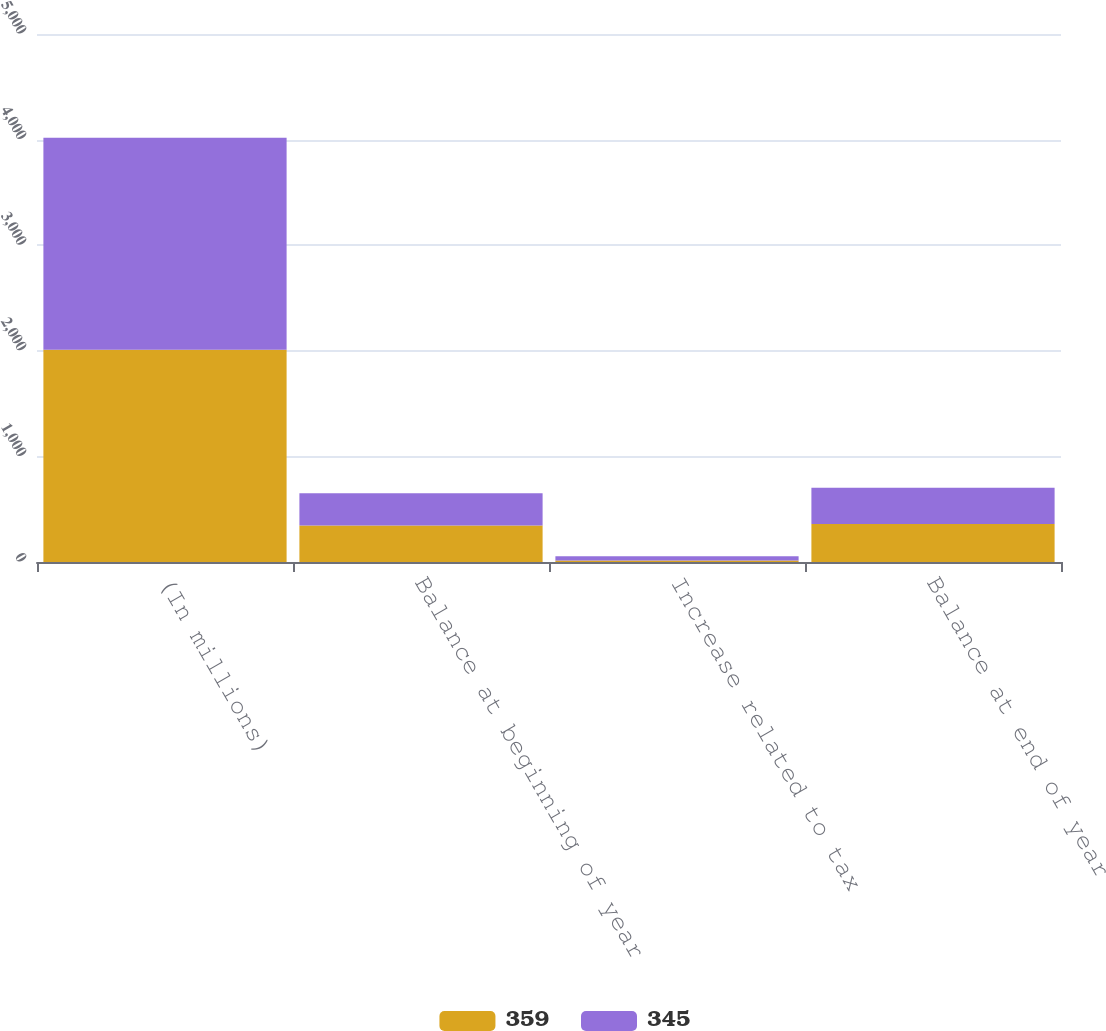Convert chart. <chart><loc_0><loc_0><loc_500><loc_500><stacked_bar_chart><ecel><fcel>(In millions)<fcel>Balance at beginning of year<fcel>Increase related to tax<fcel>Balance at end of year<nl><fcel>359<fcel>2009<fcel>345<fcel>14<fcel>359<nl><fcel>345<fcel>2008<fcel>305<fcel>41<fcel>345<nl></chart> 